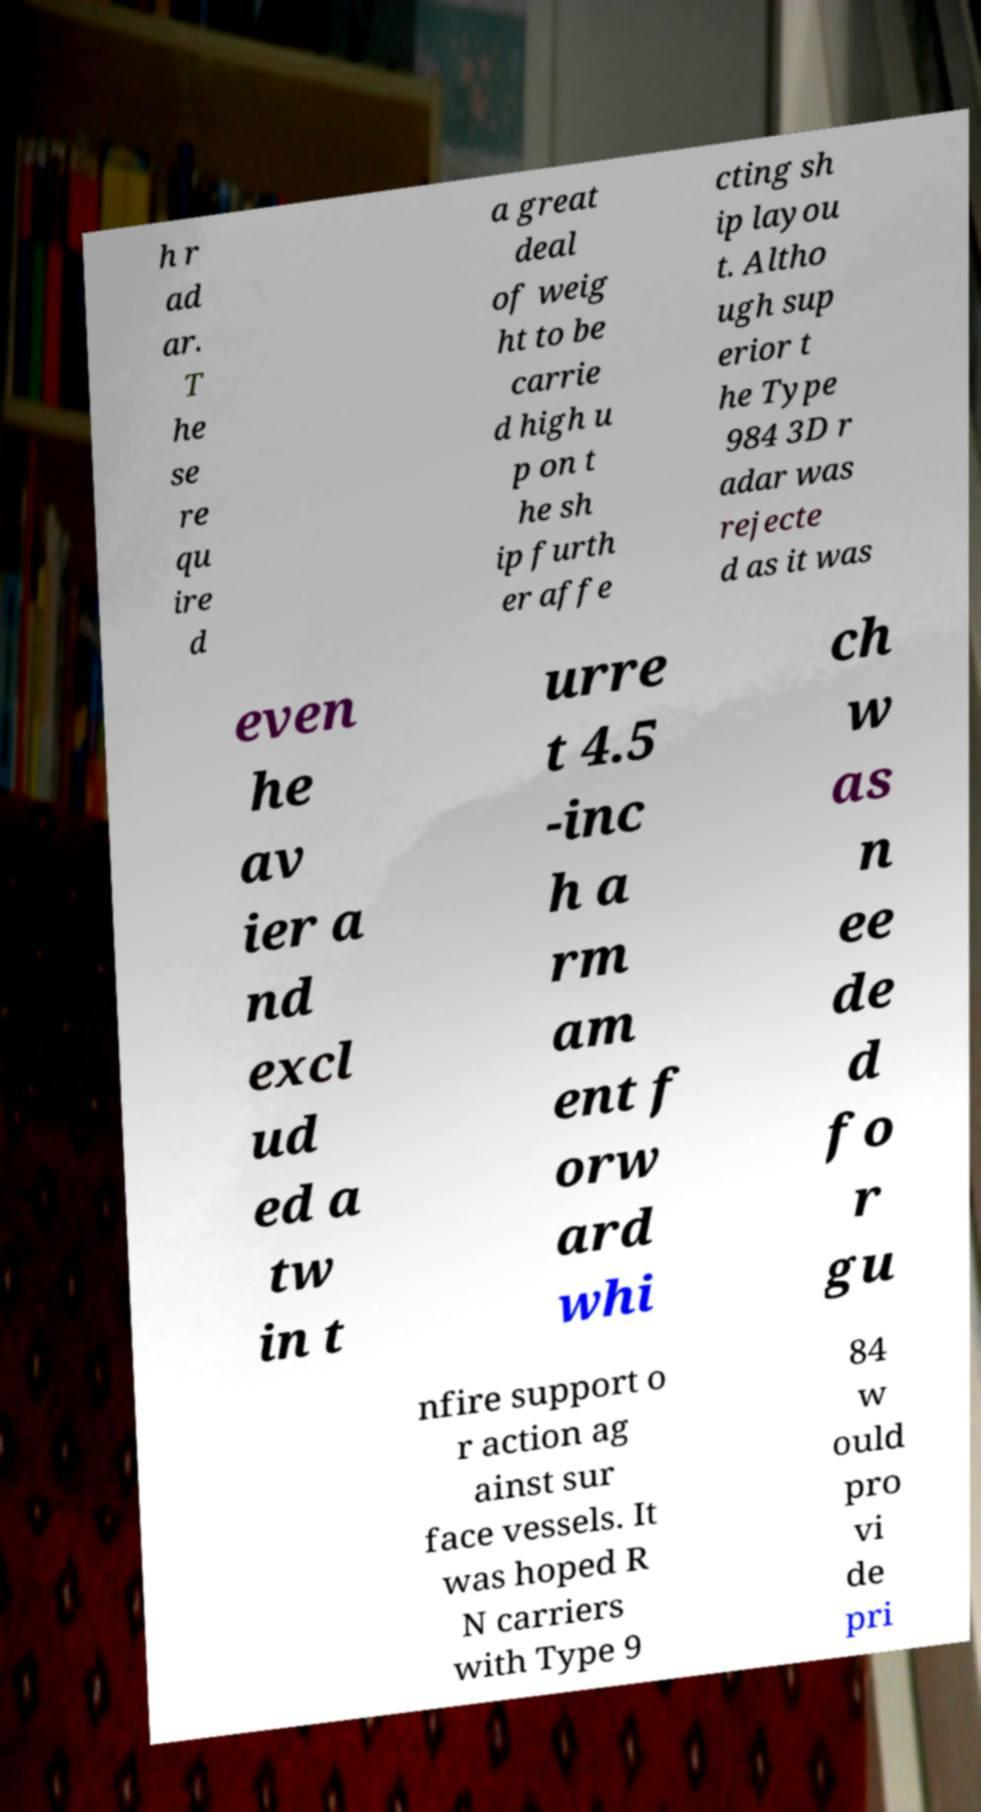There's text embedded in this image that I need extracted. Can you transcribe it verbatim? h r ad ar. T he se re qu ire d a great deal of weig ht to be carrie d high u p on t he sh ip furth er affe cting sh ip layou t. Altho ugh sup erior t he Type 984 3D r adar was rejecte d as it was even he av ier a nd excl ud ed a tw in t urre t 4.5 -inc h a rm am ent f orw ard whi ch w as n ee de d fo r gu nfire support o r action ag ainst sur face vessels. It was hoped R N carriers with Type 9 84 w ould pro vi de pri 